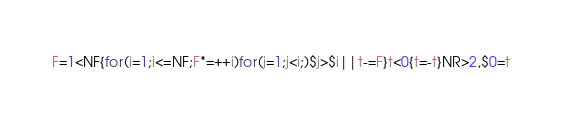<code> <loc_0><loc_0><loc_500><loc_500><_Awk_>F=1<NF{for(i=1;i<=NF;F*=++i)for(j=1;j<i;)$j>$i||t-=F}t<0{t=-t}NR>2,$0=t</code> 